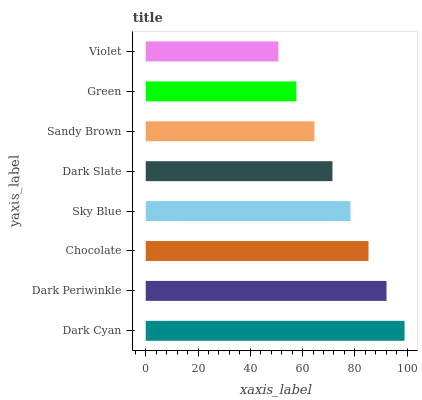Is Violet the minimum?
Answer yes or no. Yes. Is Dark Cyan the maximum?
Answer yes or no. Yes. Is Dark Periwinkle the minimum?
Answer yes or no. No. Is Dark Periwinkle the maximum?
Answer yes or no. No. Is Dark Cyan greater than Dark Periwinkle?
Answer yes or no. Yes. Is Dark Periwinkle less than Dark Cyan?
Answer yes or no. Yes. Is Dark Periwinkle greater than Dark Cyan?
Answer yes or no. No. Is Dark Cyan less than Dark Periwinkle?
Answer yes or no. No. Is Sky Blue the high median?
Answer yes or no. Yes. Is Dark Slate the low median?
Answer yes or no. Yes. Is Dark Periwinkle the high median?
Answer yes or no. No. Is Chocolate the low median?
Answer yes or no. No. 